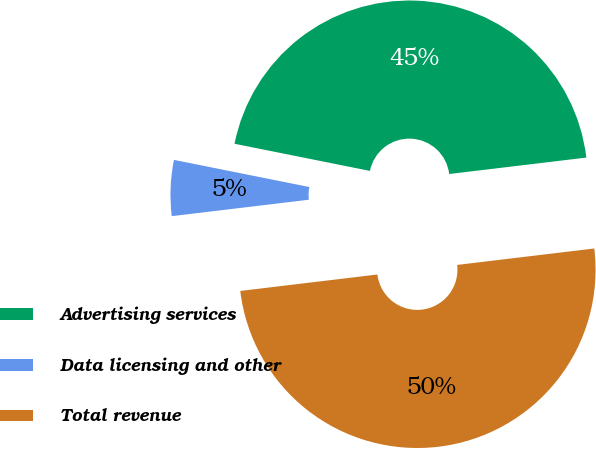Convert chart to OTSL. <chart><loc_0><loc_0><loc_500><loc_500><pie_chart><fcel>Advertising services<fcel>Data licensing and other<fcel>Total revenue<nl><fcel>44.95%<fcel>5.05%<fcel>50.0%<nl></chart> 